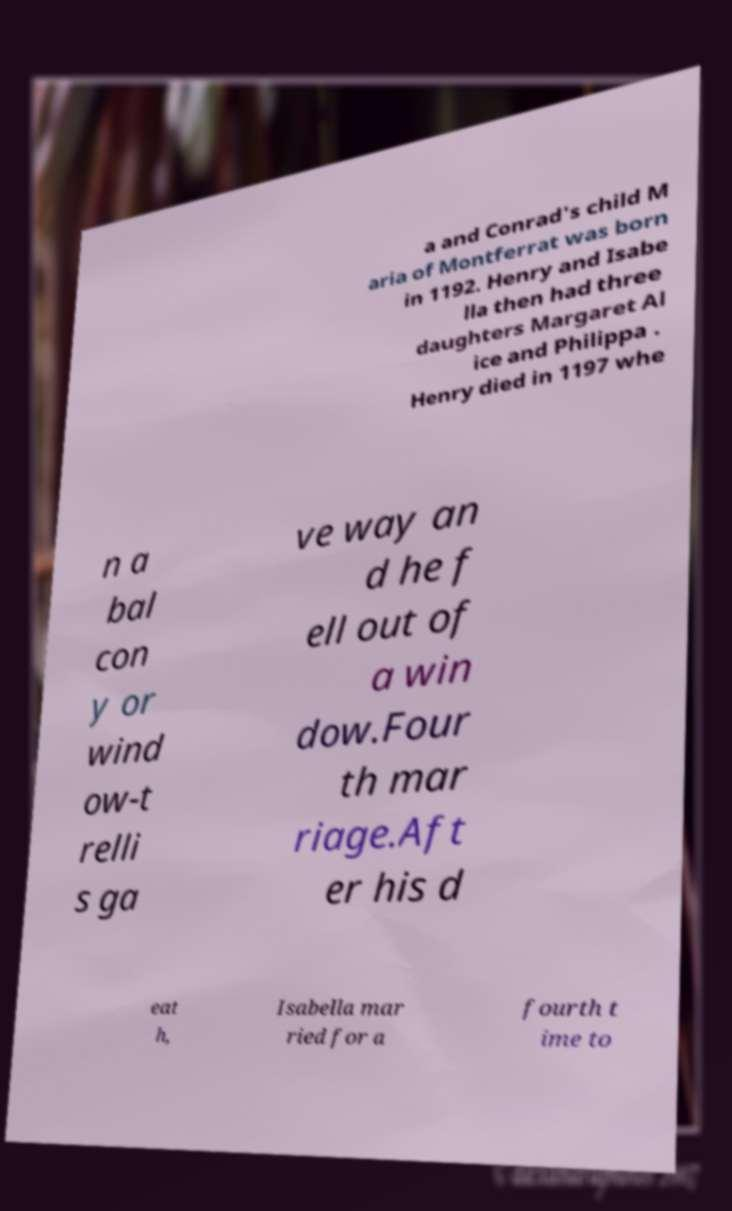There's text embedded in this image that I need extracted. Can you transcribe it verbatim? a and Conrad's child M aria of Montferrat was born in 1192. Henry and Isabe lla then had three daughters Margaret Al ice and Philippa . Henry died in 1197 whe n a bal con y or wind ow-t relli s ga ve way an d he f ell out of a win dow.Four th mar riage.Aft er his d eat h, Isabella mar ried for a fourth t ime to 